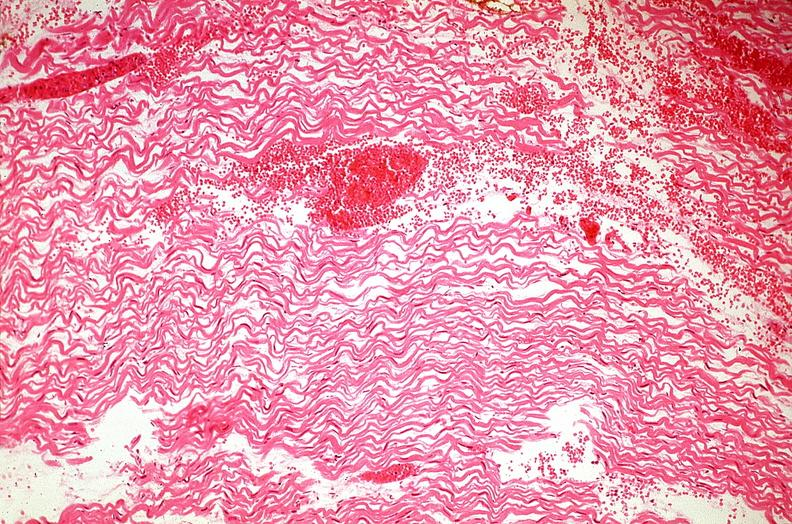does this image show heart, myocardial infarction, wavey fiber change, necrtosis, hemorrhage, and dissection?
Answer the question using a single word or phrase. Yes 